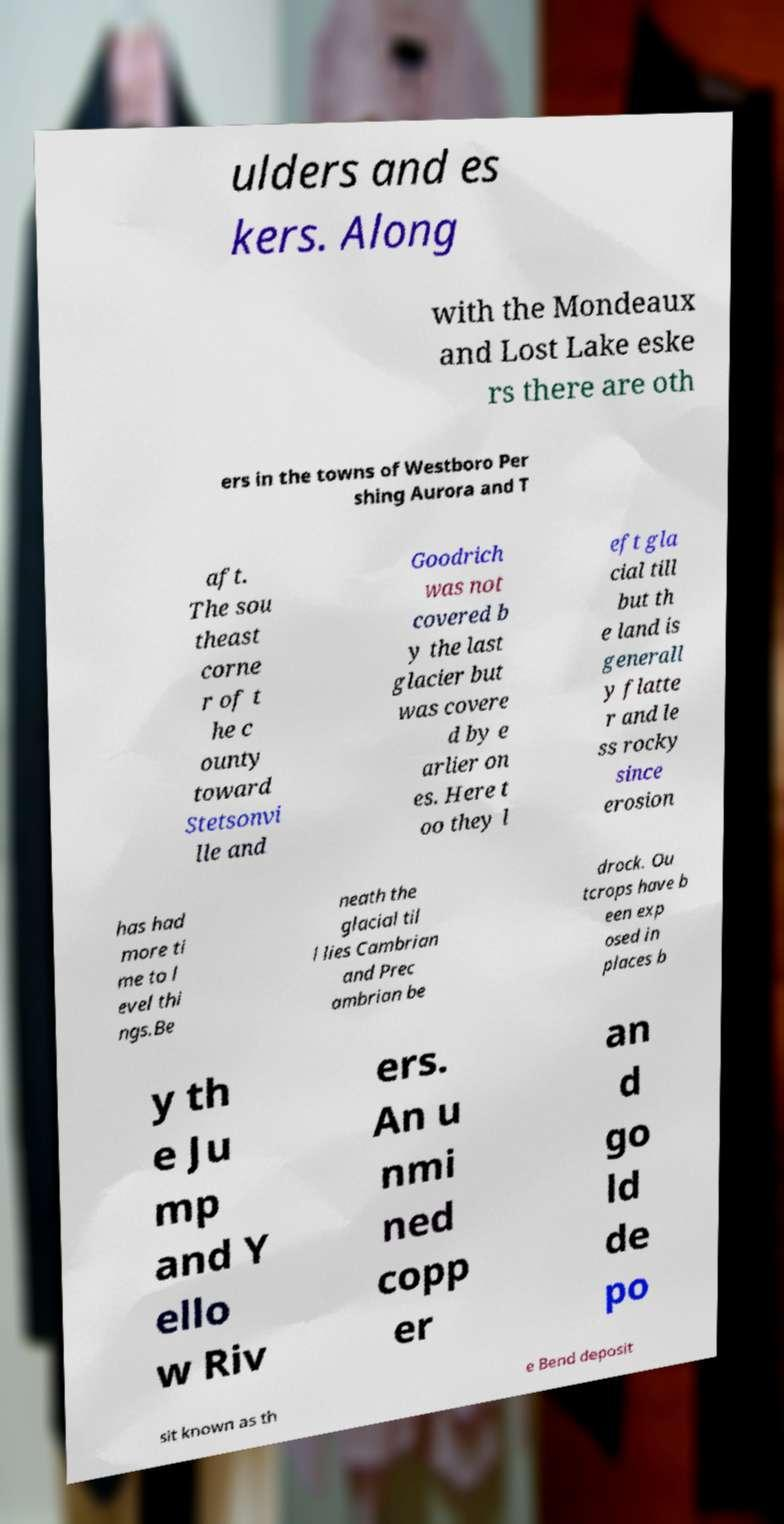What messages or text are displayed in this image? I need them in a readable, typed format. ulders and es kers. Along with the Mondeaux and Lost Lake eske rs there are oth ers in the towns of Westboro Per shing Aurora and T aft. The sou theast corne r of t he c ounty toward Stetsonvi lle and Goodrich was not covered b y the last glacier but was covere d by e arlier on es. Here t oo they l eft gla cial till but th e land is generall y flatte r and le ss rocky since erosion has had more ti me to l evel thi ngs.Be neath the glacial til l lies Cambrian and Prec ambrian be drock. Ou tcrops have b een exp osed in places b y th e Ju mp and Y ello w Riv ers. An u nmi ned copp er an d go ld de po sit known as th e Bend deposit 